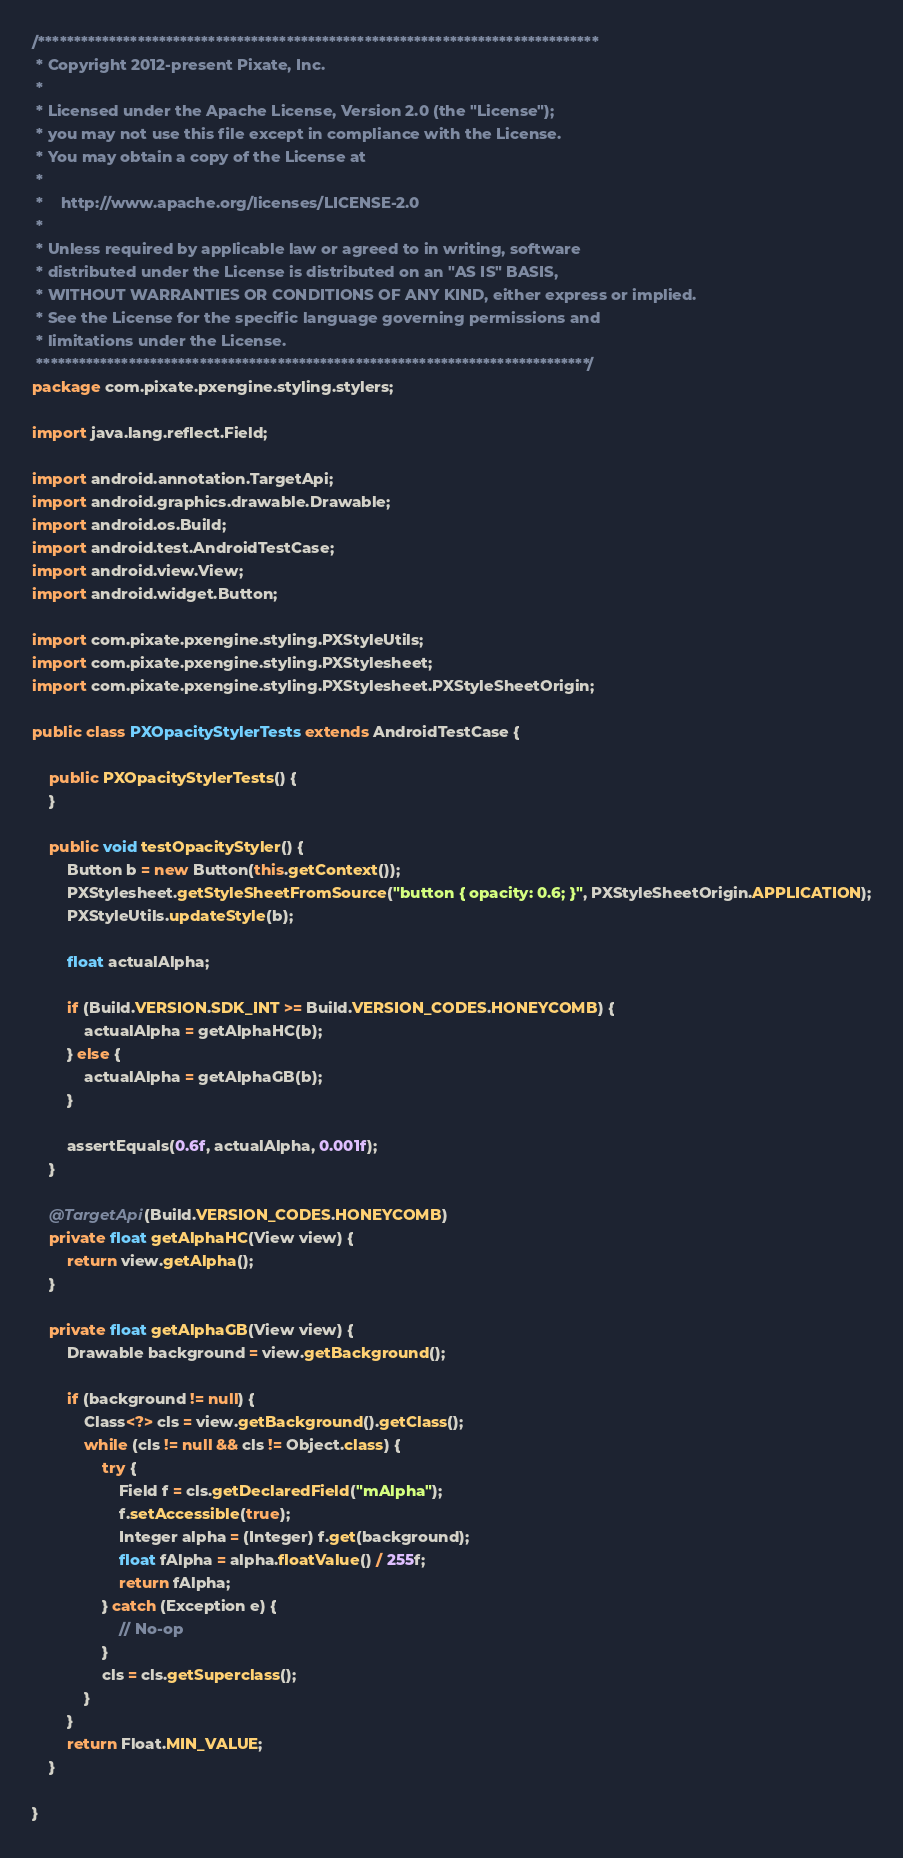<code> <loc_0><loc_0><loc_500><loc_500><_Java_>/*******************************************************************************
 * Copyright 2012-present Pixate, Inc.
 * 
 * Licensed under the Apache License, Version 2.0 (the "License");
 * you may not use this file except in compliance with the License.
 * You may obtain a copy of the License at
 * 
 *    http://www.apache.org/licenses/LICENSE-2.0
 * 
 * Unless required by applicable law or agreed to in writing, software
 * distributed under the License is distributed on an "AS IS" BASIS,
 * WITHOUT WARRANTIES OR CONDITIONS OF ANY KIND, either express or implied.
 * See the License for the specific language governing permissions and
 * limitations under the License.
 ******************************************************************************/
package com.pixate.pxengine.styling.stylers;

import java.lang.reflect.Field;

import android.annotation.TargetApi;
import android.graphics.drawable.Drawable;
import android.os.Build;
import android.test.AndroidTestCase;
import android.view.View;
import android.widget.Button;

import com.pixate.pxengine.styling.PXStyleUtils;
import com.pixate.pxengine.styling.PXStylesheet;
import com.pixate.pxengine.styling.PXStylesheet.PXStyleSheetOrigin;

public class PXOpacityStylerTests extends AndroidTestCase {

    public PXOpacityStylerTests() {
    }

    public void testOpacityStyler() {
        Button b = new Button(this.getContext());
        PXStylesheet.getStyleSheetFromSource("button { opacity: 0.6; }", PXStyleSheetOrigin.APPLICATION);
        PXStyleUtils.updateStyle(b);

        float actualAlpha;

        if (Build.VERSION.SDK_INT >= Build.VERSION_CODES.HONEYCOMB) {
            actualAlpha = getAlphaHC(b);
        } else {
            actualAlpha = getAlphaGB(b);
        }

        assertEquals(0.6f, actualAlpha, 0.001f);
    }

    @TargetApi(Build.VERSION_CODES.HONEYCOMB)
    private float getAlphaHC(View view) {
        return view.getAlpha();
    }

    private float getAlphaGB(View view) {
        Drawable background = view.getBackground();

        if (background != null) {
            Class<?> cls = view.getBackground().getClass();
            while (cls != null && cls != Object.class) {
                try {
                    Field f = cls.getDeclaredField("mAlpha");
                    f.setAccessible(true);
                    Integer alpha = (Integer) f.get(background);
                    float fAlpha = alpha.floatValue() / 255f;
                    return fAlpha;
                } catch (Exception e) {
                    // No-op
                }
                cls = cls.getSuperclass();
            }
        }
        return Float.MIN_VALUE;
    }

}
</code> 